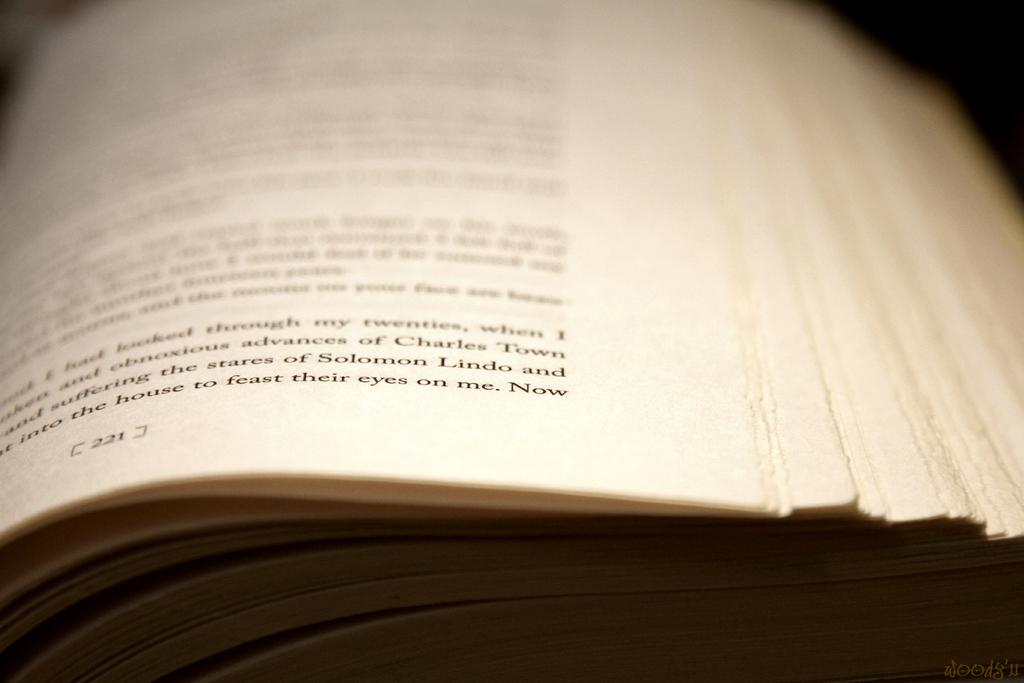<image>
Give a short and clear explanation of the subsequent image. Part of a page of a book mentios Charles Town and Solomon Lindo. 